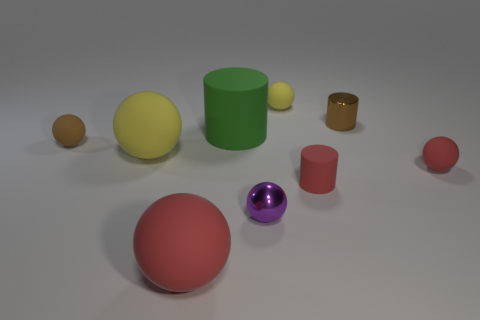There is a tiny ball that is the same color as the small matte cylinder; what material is it?
Offer a very short reply. Rubber. There is a small rubber object that is the same color as the shiny cylinder; what shape is it?
Keep it short and to the point. Sphere. What number of spheres are blue matte things or tiny things?
Provide a short and direct response. 4. There is a matte cylinder that is the same size as the purple thing; what is its color?
Offer a terse response. Red. There is a red matte thing to the left of the yellow thing to the right of the purple shiny thing; what shape is it?
Your answer should be compact. Sphere. Is the size of the yellow ball that is to the left of the purple shiny ball the same as the big red ball?
Offer a terse response. Yes. What number of other things are the same material as the green thing?
Keep it short and to the point. 6. What number of purple objects are shiny balls or shiny cylinders?
Provide a short and direct response. 1. What is the size of the sphere that is the same color as the tiny metal cylinder?
Provide a short and direct response. Small. What number of things are on the right side of the large red matte sphere?
Your answer should be very brief. 6. 